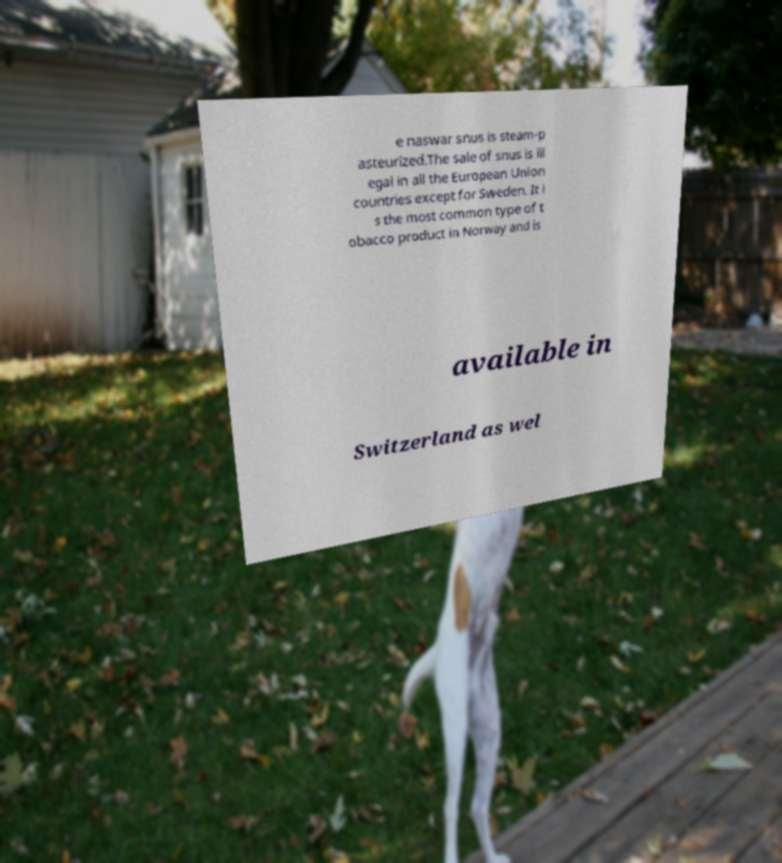Please identify and transcribe the text found in this image. e naswar snus is steam-p asteurized.The sale of snus is ill egal in all the European Union countries except for Sweden. It i s the most common type of t obacco product in Norway and is available in Switzerland as wel 